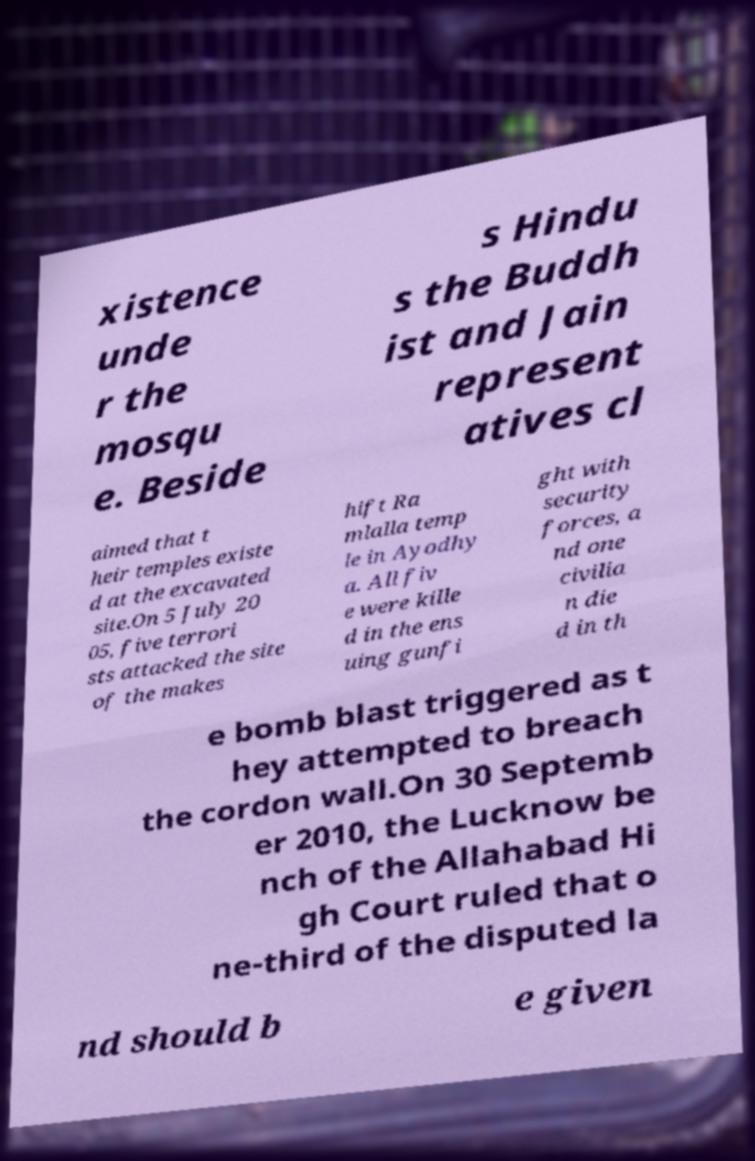For documentation purposes, I need the text within this image transcribed. Could you provide that? xistence unde r the mosqu e. Beside s Hindu s the Buddh ist and Jain represent atives cl aimed that t heir temples existe d at the excavated site.On 5 July 20 05, five terrori sts attacked the site of the makes hift Ra mlalla temp le in Ayodhy a. All fiv e were kille d in the ens uing gunfi ght with security forces, a nd one civilia n die d in th e bomb blast triggered as t hey attempted to breach the cordon wall.On 30 Septemb er 2010, the Lucknow be nch of the Allahabad Hi gh Court ruled that o ne-third of the disputed la nd should b e given 